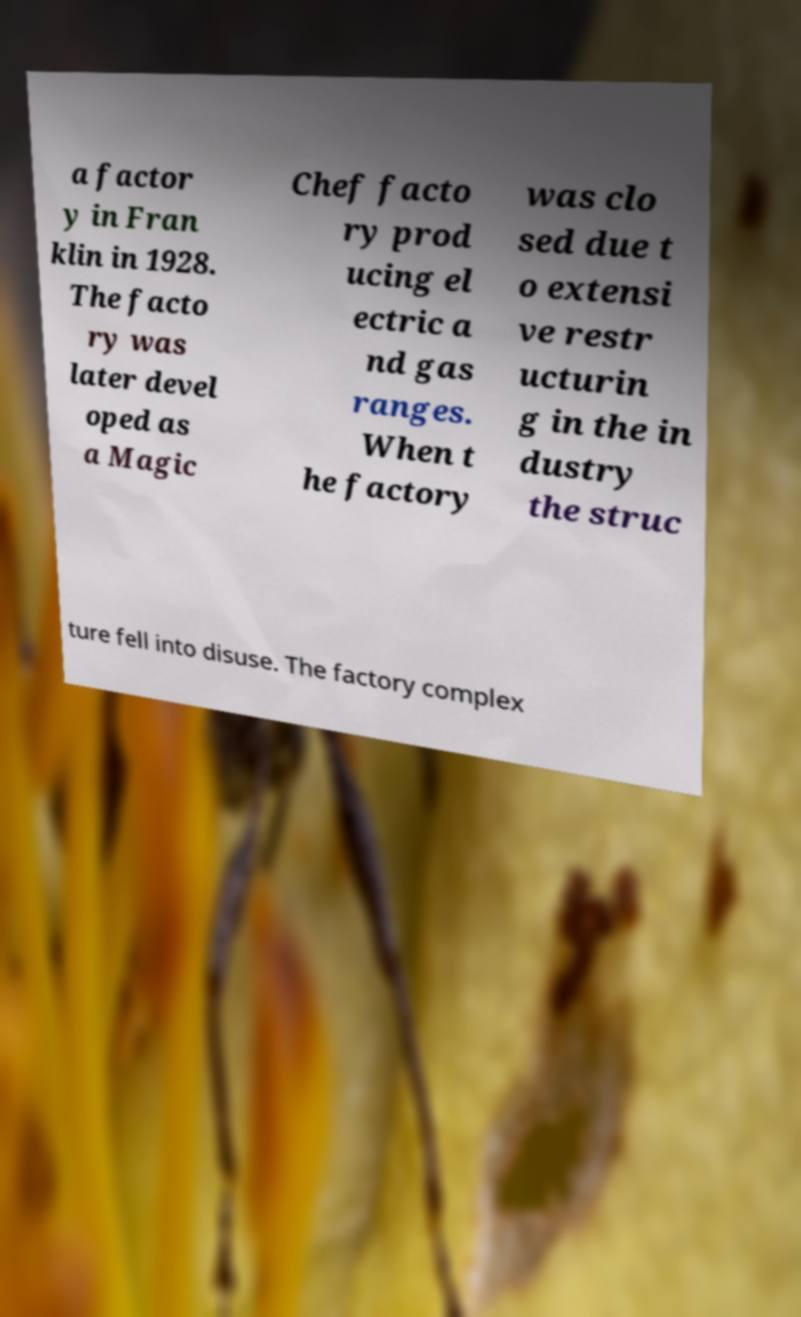Please read and relay the text visible in this image. What does it say? a factor y in Fran klin in 1928. The facto ry was later devel oped as a Magic Chef facto ry prod ucing el ectric a nd gas ranges. When t he factory was clo sed due t o extensi ve restr ucturin g in the in dustry the struc ture fell into disuse. The factory complex 